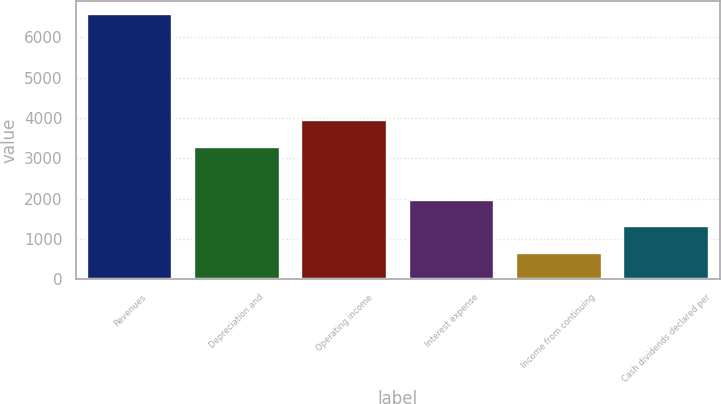Convert chart to OTSL. <chart><loc_0><loc_0><loc_500><loc_500><bar_chart><fcel>Revenues<fcel>Depreciation and<fcel>Operating income<fcel>Interest expense<fcel>Income from continuing<fcel>Cash dividends declared per<nl><fcel>6572<fcel>3286.6<fcel>3943.68<fcel>1972.44<fcel>658.28<fcel>1315.36<nl></chart> 